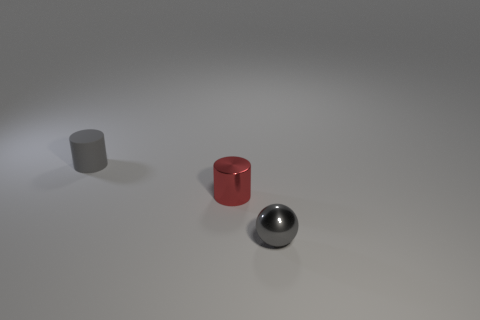Add 1 small gray metallic balls. How many objects exist? 4 Subtract all cylinders. How many objects are left? 1 Add 1 tiny red shiny cylinders. How many tiny red shiny cylinders exist? 2 Subtract 0 blue cylinders. How many objects are left? 3 Subtract all small red cylinders. Subtract all red cylinders. How many objects are left? 1 Add 2 small gray rubber objects. How many small gray rubber objects are left? 3 